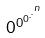Convert formula to latex. <formula><loc_0><loc_0><loc_500><loc_500>0 ^ { 0 ^ { 0 ^ { . ^ { . ^ { n } } } } }</formula> 